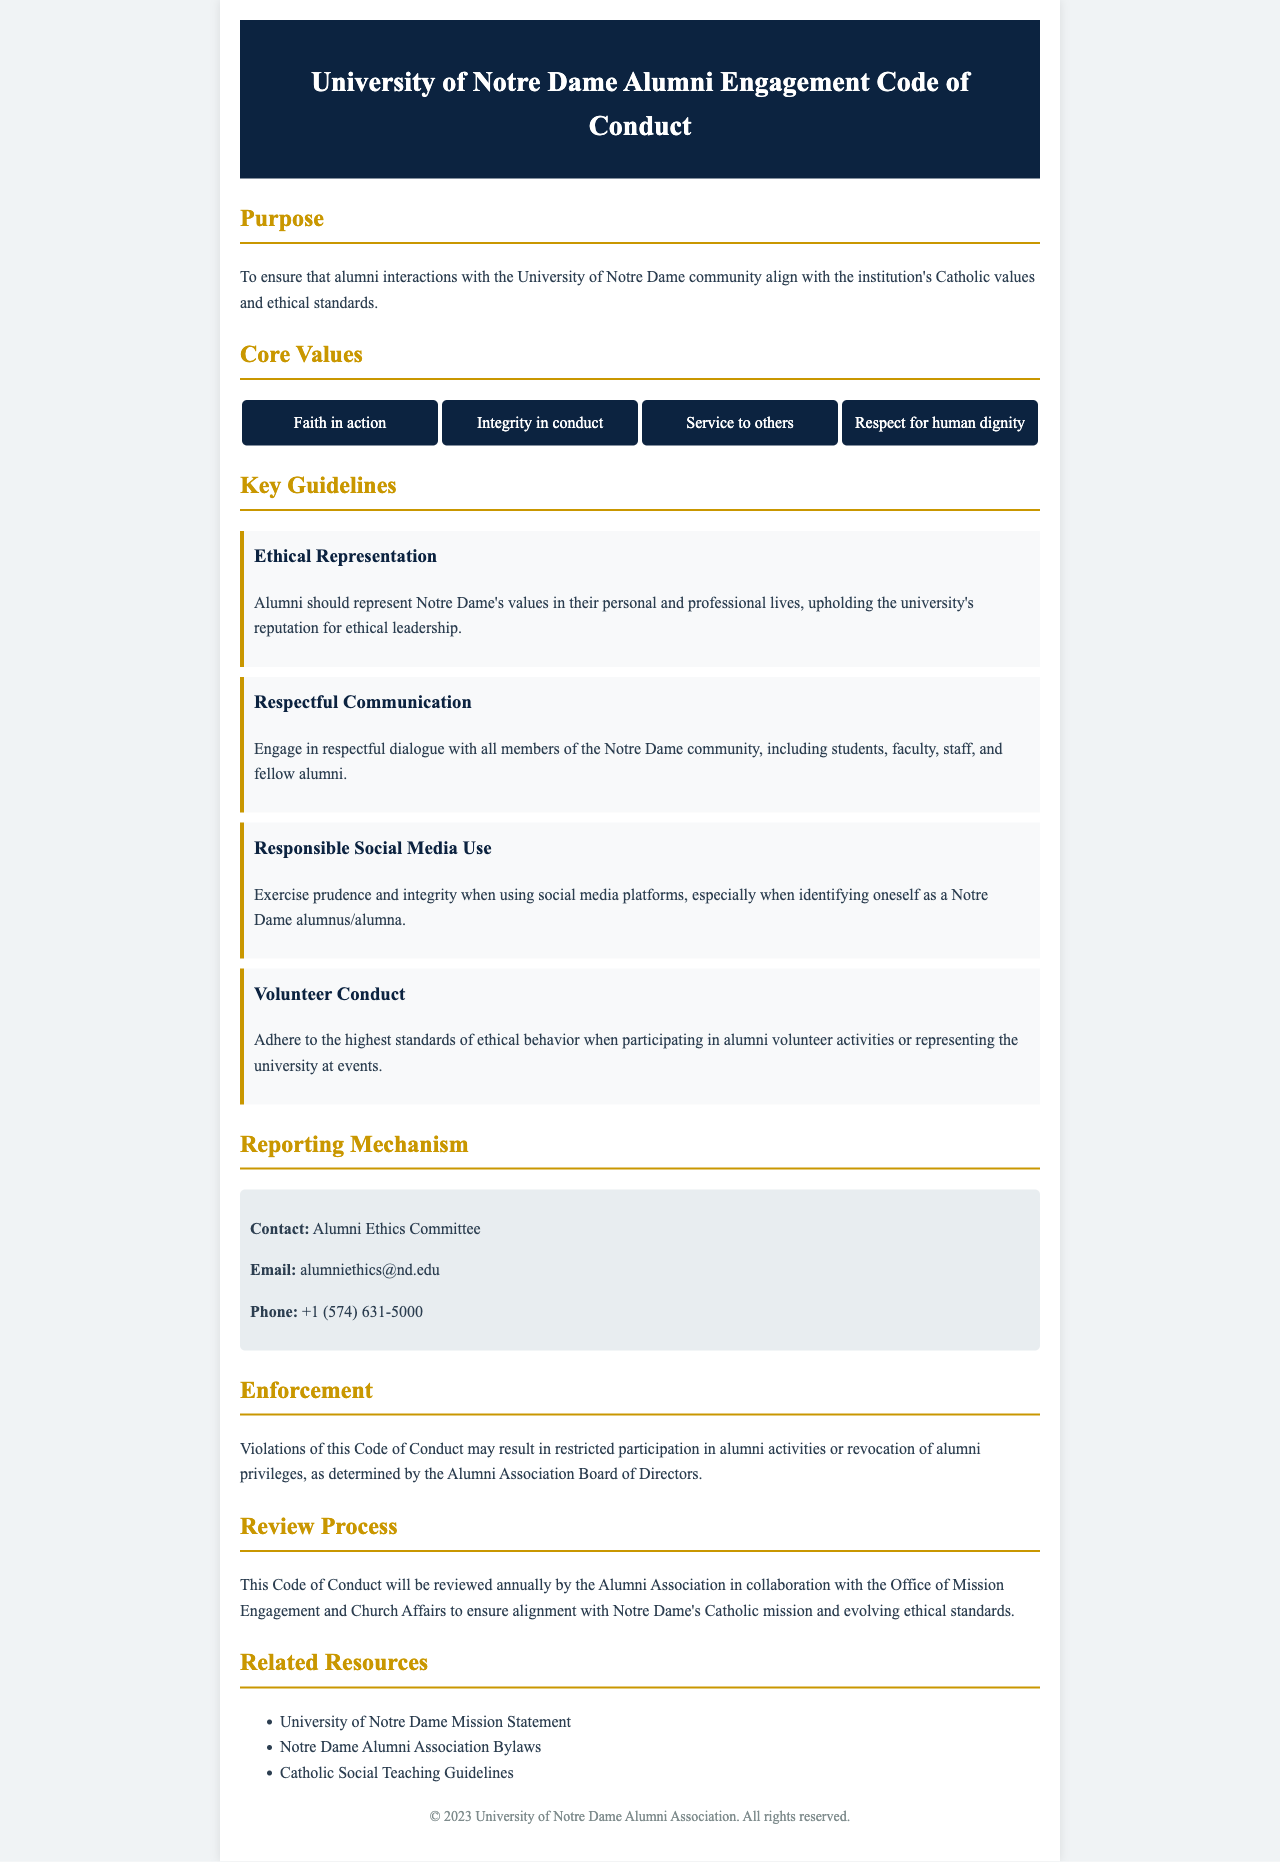What is the purpose of the Code of Conduct? The purpose is to ensure that alumni interactions with the University of Notre Dame community align with the institution's Catholic values and ethical standards.
Answer: To ensure that alumni interactions align with Catholic values and ethical standards What are the core values listed in the document? The document lists four core values that embody the guiding principles for alumni engagement.
Answer: Faith in action, Integrity in conduct, Service to others, Respect for human dignity Who should alumni contact for ethical concerns? The contact information for reporting ethical concerns includes a specific committee's email and phone number.
Answer: Alumni Ethics Committee What consequence is mentioned for violations of the Code of Conduct? The document indicates potential consequences for violations, specifically concerning participation and privileges.
Answer: Restricted participation or revocation of alumni privileges How often will the Code of Conduct be reviewed? The review process for the document specifies a frequency of annual review with involved parties noted.
Answer: Annually What type of communication is emphasized in the guidelines? One of the key guidelines stresses the importance of how alumni communicate with each other and the broader community.
Answer: Respectful communication What is required when representing Notre Dame at events? The Code specifies a standard regarding behavior for alumni during university-related events and activities.
Answer: Highest standards of ethical behavior Which committee collaborates with the Alumni Association for the review process? The review process involves collaboration with another office within the university, enhancing oversight and mission alignment.
Answer: Office of Mission Engagement and Church Affairs 